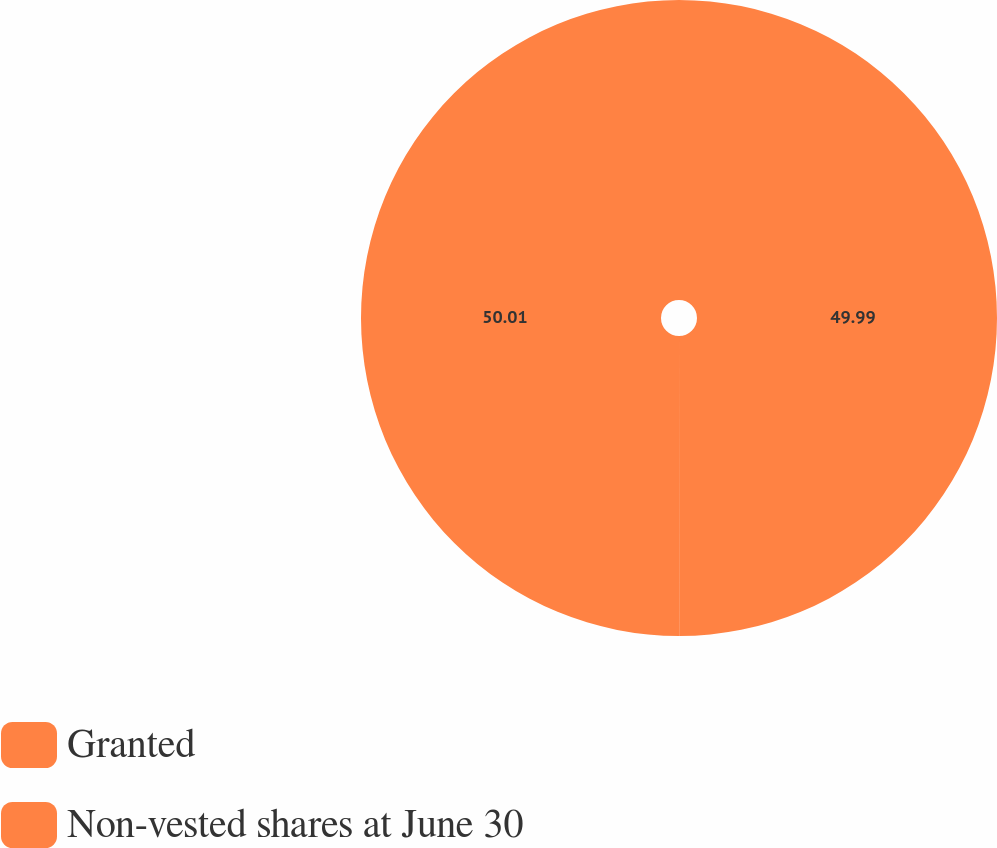Convert chart. <chart><loc_0><loc_0><loc_500><loc_500><pie_chart><fcel>Granted<fcel>Non-vested shares at June 30<nl><fcel>49.99%<fcel>50.01%<nl></chart> 